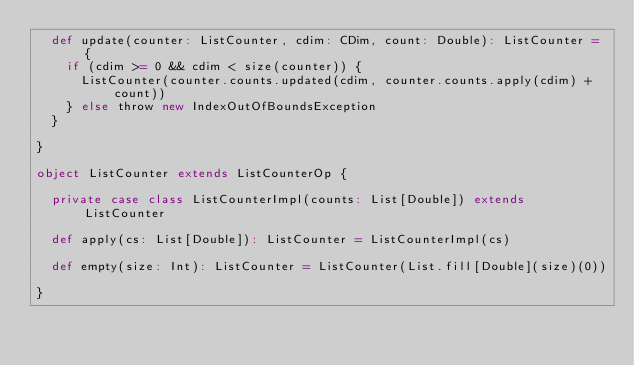Convert code to text. <code><loc_0><loc_0><loc_500><loc_500><_Scala_>  def update(counter: ListCounter, cdim: CDim, count: Double): ListCounter = {
    if (cdim >= 0 && cdim < size(counter)) {
      ListCounter(counter.counts.updated(cdim, counter.counts.apply(cdim) + count))
    } else throw new IndexOutOfBoundsException
  }

}

object ListCounter extends ListCounterOp {

  private case class ListCounterImpl(counts: List[Double]) extends ListCounter

  def apply(cs: List[Double]): ListCounter = ListCounterImpl(cs)

  def empty(size: Int): ListCounter = ListCounter(List.fill[Double](size)(0))

}
</code> 